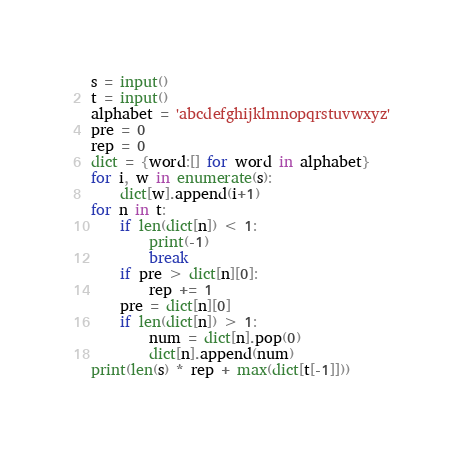<code> <loc_0><loc_0><loc_500><loc_500><_Python_>s = input()
t = input()
alphabet = 'abcdefghijklmnopqrstuvwxyz'
pre = 0
rep = 0
dict = {word:[] for word in alphabet}
for i, w in enumerate(s):
    dict[w].append(i+1)
for n in t:
    if len(dict[n]) < 1:
        print(-1)
        break
    if pre > dict[n][0]:
        rep += 1
    pre = dict[n][0]
    if len(dict[n]) > 1:
        num = dict[n].pop(0)
        dict[n].append(num)
print(len(s) * rep + max(dict[t[-1]]))</code> 